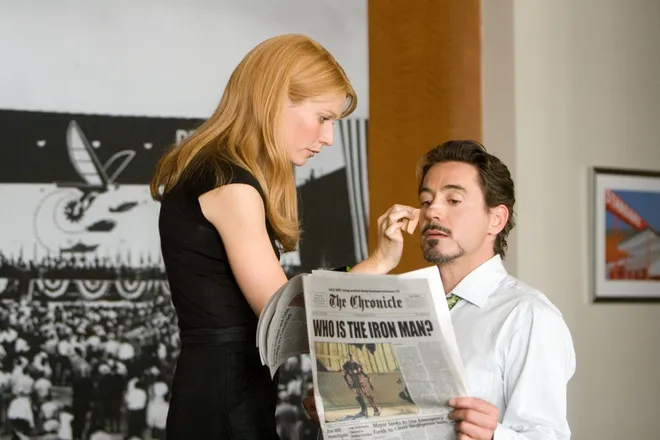What might be the significance of the newspaper headline in the context of the movie? The newspaper headline 'Who is the Iron Man?' plays a critical role in the plot of 'Iron Man'. It symbolizes the public's curiosity and the media's pursuit of the true identity behind the Iron Man suit. For Tony Stark, it represents a challenge to his decision about whether to reveal his identity or keep it hidden, impacting his personal and public life significantly. 